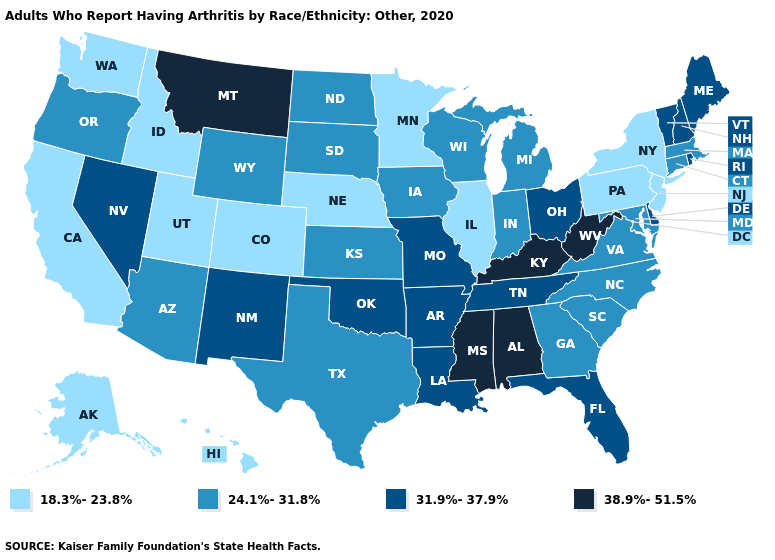Name the states that have a value in the range 24.1%-31.8%?
Keep it brief. Arizona, Connecticut, Georgia, Indiana, Iowa, Kansas, Maryland, Massachusetts, Michigan, North Carolina, North Dakota, Oregon, South Carolina, South Dakota, Texas, Virginia, Wisconsin, Wyoming. Does Montana have the highest value in the West?
Quick response, please. Yes. Among the states that border Michigan , which have the highest value?
Concise answer only. Ohio. What is the highest value in states that border Colorado?
Answer briefly. 31.9%-37.9%. What is the value of Maine?
Be succinct. 31.9%-37.9%. Does Nevada have the lowest value in the West?
Answer briefly. No. Does Kansas have a lower value than Arizona?
Quick response, please. No. Which states have the lowest value in the USA?
Write a very short answer. Alaska, California, Colorado, Hawaii, Idaho, Illinois, Minnesota, Nebraska, New Jersey, New York, Pennsylvania, Utah, Washington. Among the states that border Virginia , which have the lowest value?
Quick response, please. Maryland, North Carolina. Does Tennessee have a lower value than Connecticut?
Keep it brief. No. Which states have the lowest value in the USA?
Quick response, please. Alaska, California, Colorado, Hawaii, Idaho, Illinois, Minnesota, Nebraska, New Jersey, New York, Pennsylvania, Utah, Washington. Which states have the lowest value in the MidWest?
Give a very brief answer. Illinois, Minnesota, Nebraska. Among the states that border Wisconsin , which have the lowest value?
Short answer required. Illinois, Minnesota. Name the states that have a value in the range 38.9%-51.5%?
Short answer required. Alabama, Kentucky, Mississippi, Montana, West Virginia. What is the lowest value in states that border Arizona?
Answer briefly. 18.3%-23.8%. 